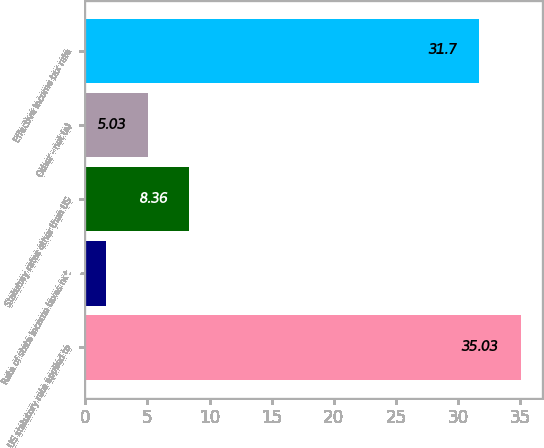Convert chart. <chart><loc_0><loc_0><loc_500><loc_500><bar_chart><fcel>US statutory rate applied to<fcel>Rate of state income taxes net<fcel>Statutory rates other than US<fcel>Other - net (a)<fcel>Effective income tax rate<nl><fcel>35.03<fcel>1.7<fcel>8.36<fcel>5.03<fcel>31.7<nl></chart> 